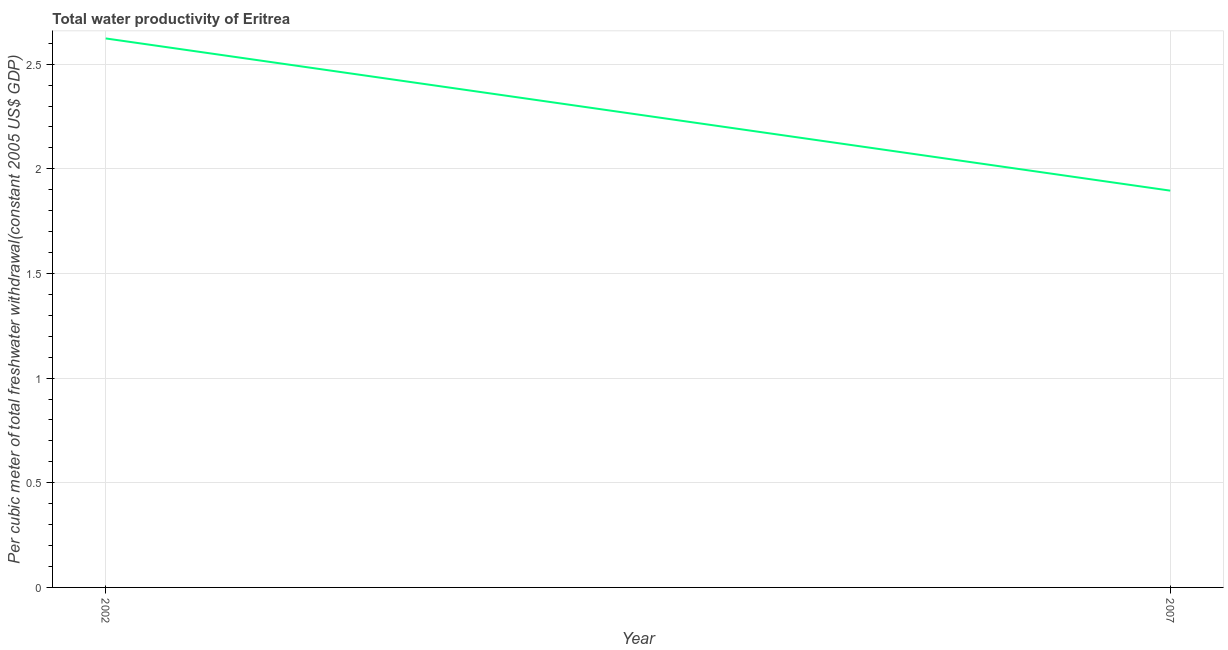What is the total water productivity in 2007?
Your response must be concise. 1.9. Across all years, what is the maximum total water productivity?
Your response must be concise. 2.62. Across all years, what is the minimum total water productivity?
Offer a terse response. 1.9. In which year was the total water productivity maximum?
Make the answer very short. 2002. What is the sum of the total water productivity?
Provide a short and direct response. 4.52. What is the difference between the total water productivity in 2002 and 2007?
Give a very brief answer. 0.73. What is the average total water productivity per year?
Ensure brevity in your answer.  2.26. What is the median total water productivity?
Your answer should be very brief. 2.26. Do a majority of the years between 2002 and 2007 (inclusive) have total water productivity greater than 0.2 US$?
Offer a terse response. Yes. What is the ratio of the total water productivity in 2002 to that in 2007?
Give a very brief answer. 1.38. Is the total water productivity in 2002 less than that in 2007?
Make the answer very short. No. In how many years, is the total water productivity greater than the average total water productivity taken over all years?
Keep it short and to the point. 1. How many lines are there?
Give a very brief answer. 1. What is the difference between two consecutive major ticks on the Y-axis?
Your answer should be very brief. 0.5. Are the values on the major ticks of Y-axis written in scientific E-notation?
Provide a short and direct response. No. What is the title of the graph?
Your response must be concise. Total water productivity of Eritrea. What is the label or title of the X-axis?
Provide a short and direct response. Year. What is the label or title of the Y-axis?
Provide a succinct answer. Per cubic meter of total freshwater withdrawal(constant 2005 US$ GDP). What is the Per cubic meter of total freshwater withdrawal(constant 2005 US$ GDP) in 2002?
Make the answer very short. 2.62. What is the Per cubic meter of total freshwater withdrawal(constant 2005 US$ GDP) of 2007?
Offer a very short reply. 1.9. What is the difference between the Per cubic meter of total freshwater withdrawal(constant 2005 US$ GDP) in 2002 and 2007?
Your answer should be very brief. 0.73. What is the ratio of the Per cubic meter of total freshwater withdrawal(constant 2005 US$ GDP) in 2002 to that in 2007?
Ensure brevity in your answer.  1.38. 